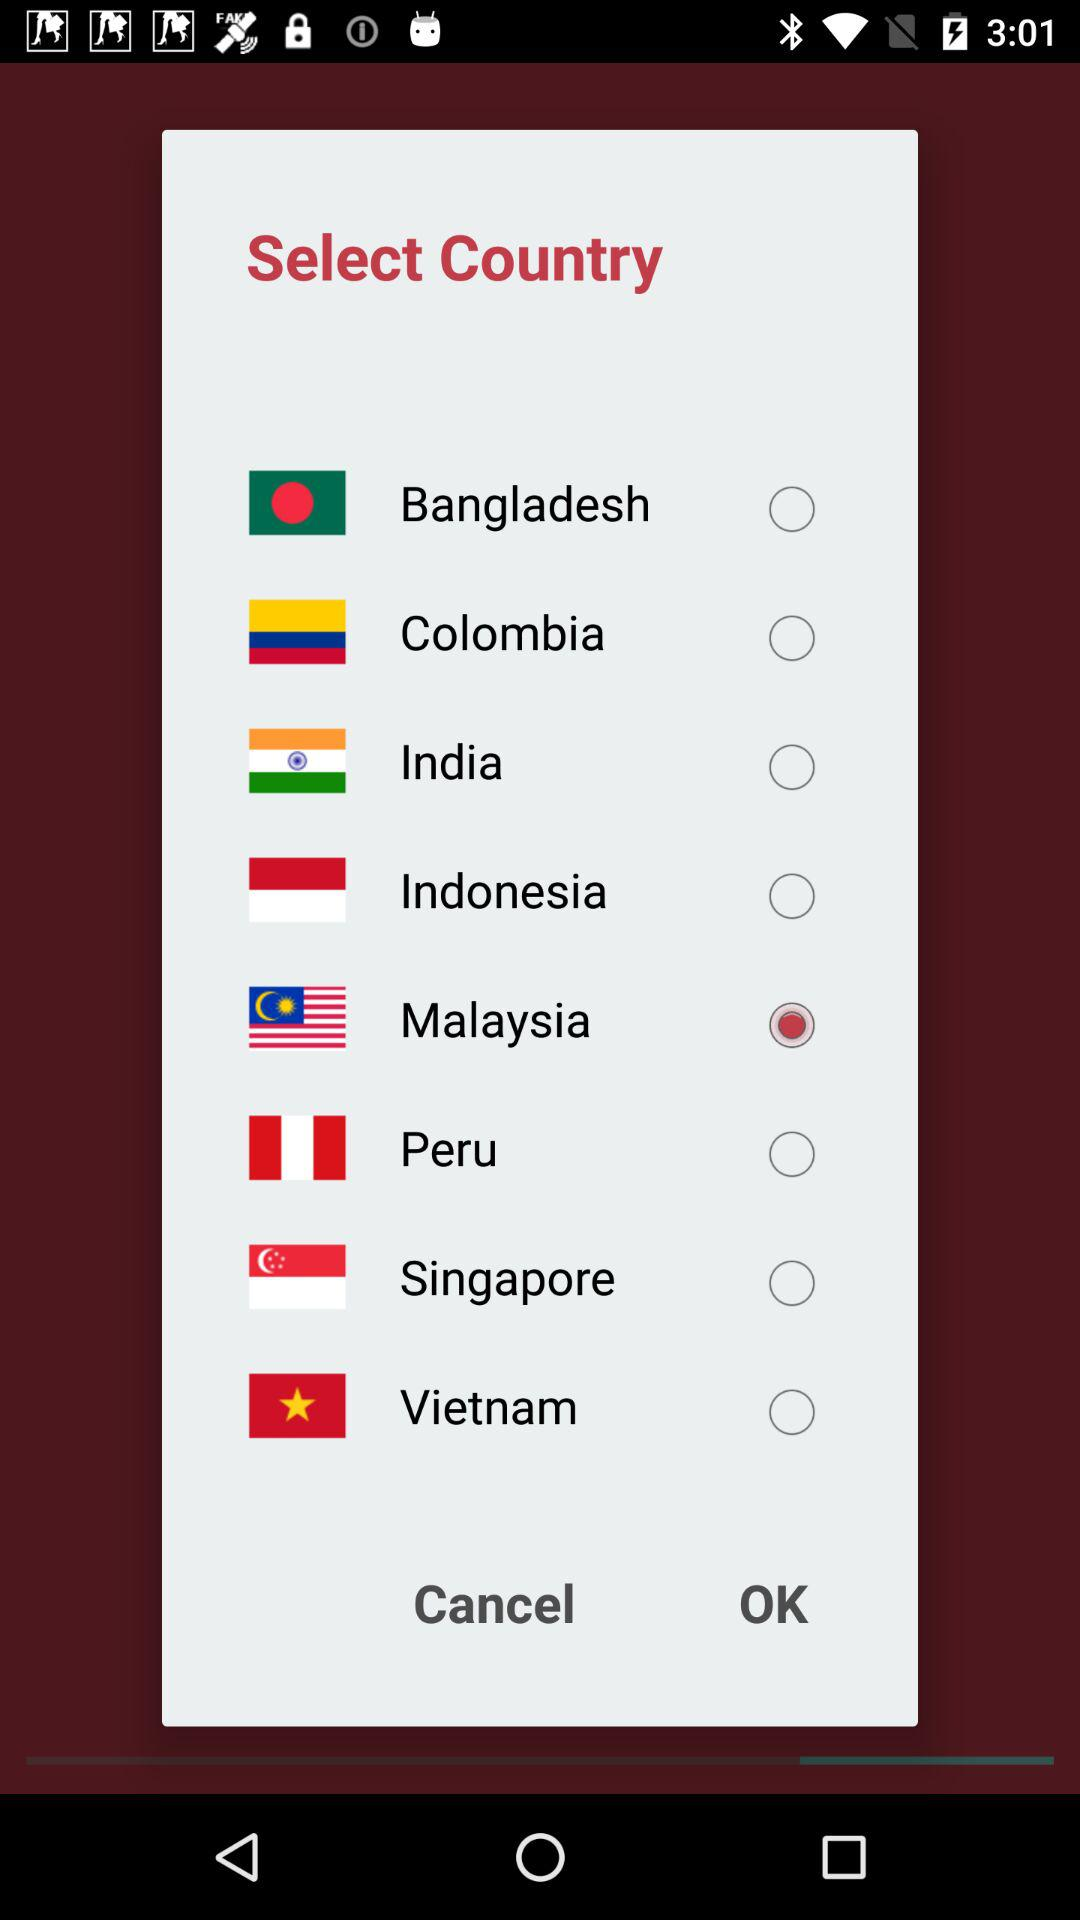What is the selected country? The selected country is Malaysia. 